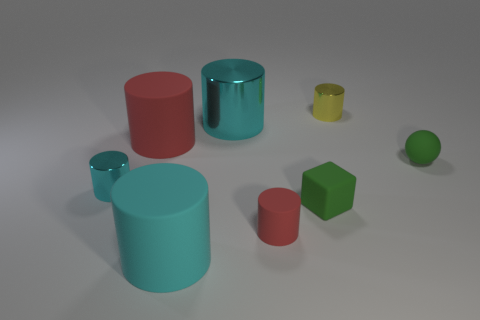What is the color of the small rubber block?
Keep it short and to the point. Green. There is a rubber sphere that is on the right side of the yellow metallic object; is its color the same as the shiny cylinder left of the large metal thing?
Provide a succinct answer. No. What size is the matte cube?
Offer a very short reply. Small. What size is the cyan metallic cylinder that is in front of the small matte ball?
Give a very brief answer. Small. There is a cyan object that is both in front of the big metallic cylinder and behind the matte cube; what is its shape?
Provide a short and direct response. Cylinder. What number of other things are the same shape as the small red rubber thing?
Keep it short and to the point. 5. There is another rubber cylinder that is the same size as the cyan matte cylinder; what is its color?
Provide a succinct answer. Red. What number of things are either tiny cyan cylinders or matte cylinders?
Provide a succinct answer. 4. There is a small yellow metal thing; are there any small cyan cylinders behind it?
Your response must be concise. No. Are there any cyan objects that have the same material as the small cube?
Keep it short and to the point. Yes. 